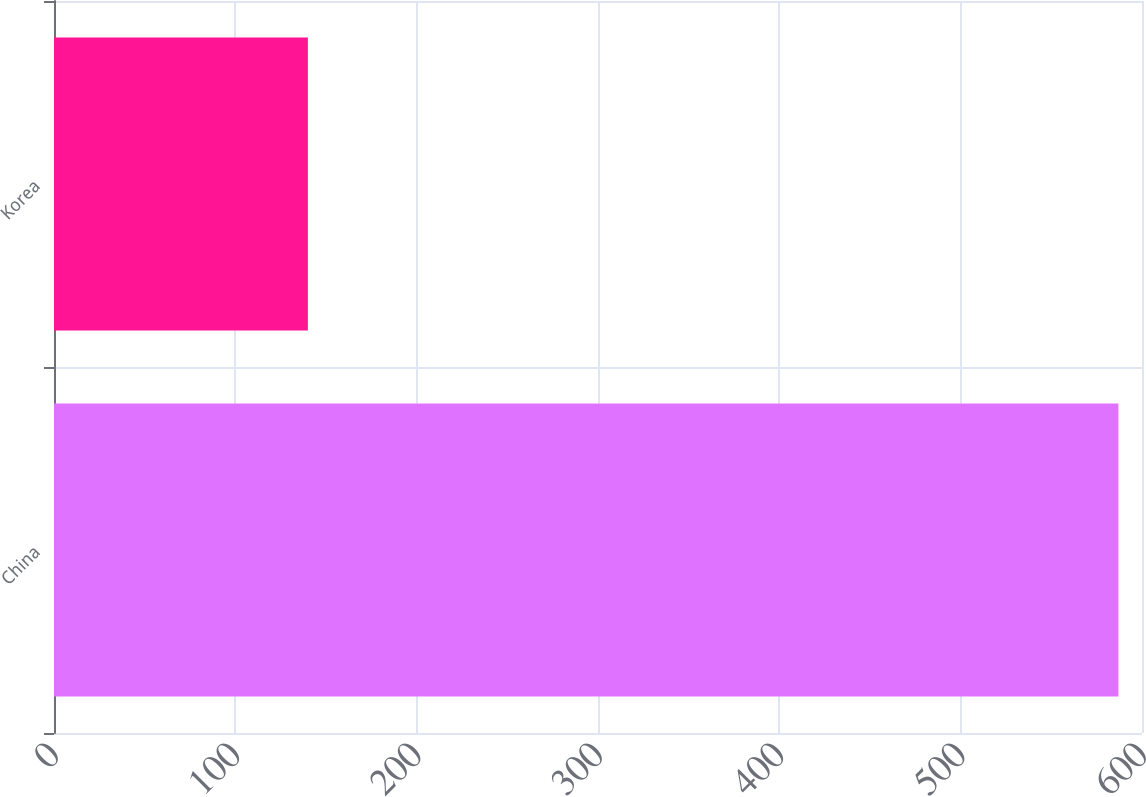Convert chart to OTSL. <chart><loc_0><loc_0><loc_500><loc_500><bar_chart><fcel>China<fcel>Korea<nl><fcel>587<fcel>140<nl></chart> 